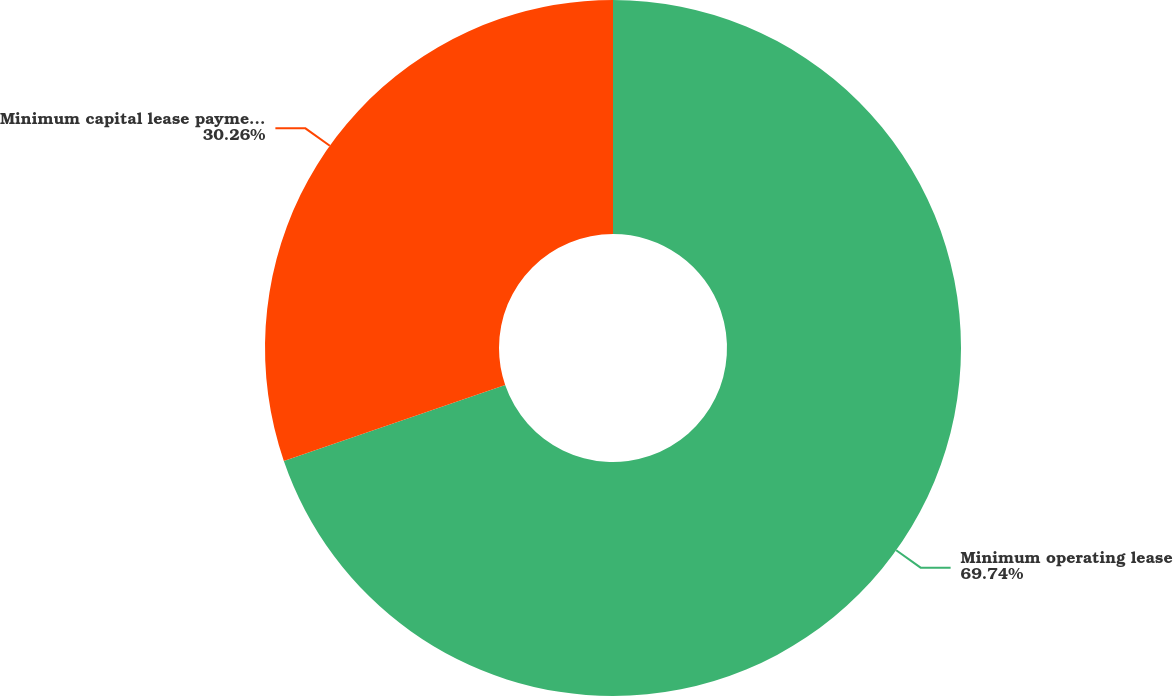<chart> <loc_0><loc_0><loc_500><loc_500><pie_chart><fcel>Minimum operating lease<fcel>Minimum capital lease payments<nl><fcel>69.74%<fcel>30.26%<nl></chart> 